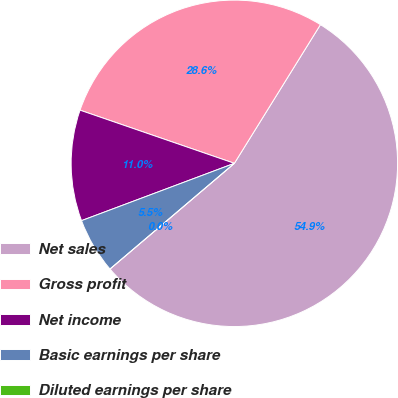Convert chart. <chart><loc_0><loc_0><loc_500><loc_500><pie_chart><fcel>Net sales<fcel>Gross profit<fcel>Net income<fcel>Basic earnings per share<fcel>Diluted earnings per share<nl><fcel>54.95%<fcel>28.56%<fcel>10.99%<fcel>5.5%<fcel>0.0%<nl></chart> 